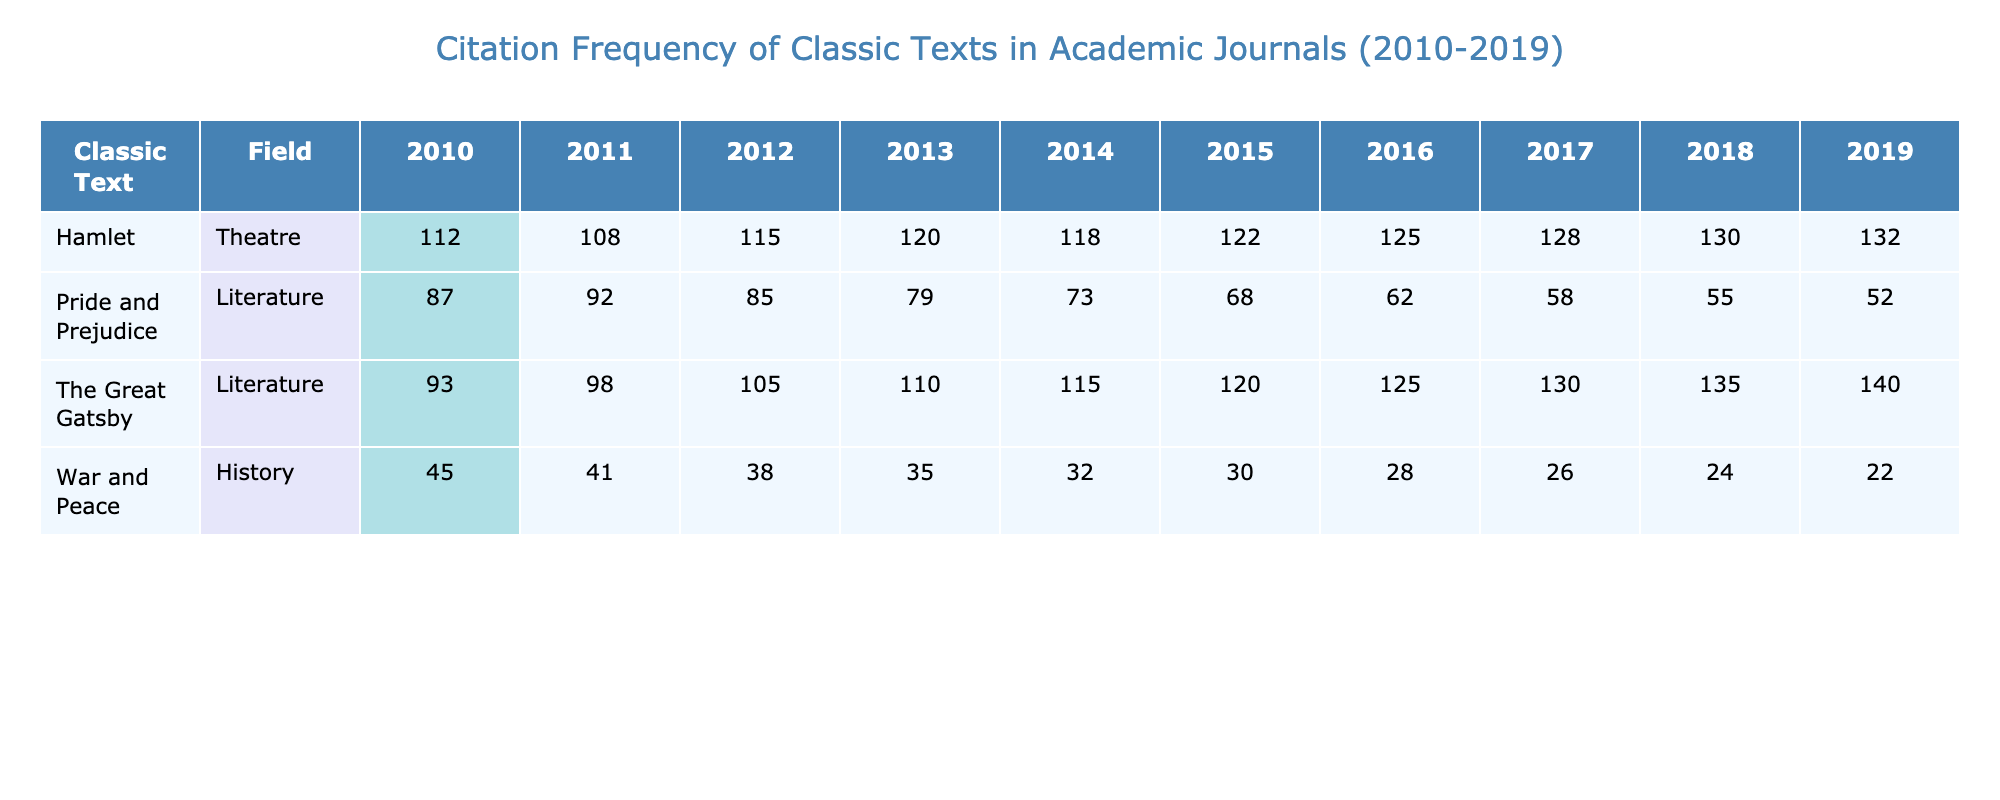What classic text had the highest number of citations in 2016? In the year 2016, the citations for the classic texts are as follows: Pride and Prejudice (62), Hamlet (125), The Great Gatsby (125), and War and Peace (28). Both Hamlet and The Great Gatsby have the highest citations at 125.
Answer: Hamlet and The Great Gatsby Which classic text consistently received the most citations across the years? By reviewing the citation counts, Hamlet received the following citations: 112, 108, 115, 120, 122, 125, 128, 130, 132. This shows a consistent upward trend and the highest range overall. Other texts show fluctuations but Hamlet is consistently among the highest per year.
Answer: Hamlet What was the difference in citations between War and Peace in 2010 and in 2019? In 2010, War and Peace had 45 citations, while in 2019 it had 22 citations. Therefore, the difference in citations is 45 - 22 = 23.
Answer: 23 Did The Great Gatsby receive more citations in 2019 than in 2010? In 2010, The Great Gatsby received 93 citations, while in 2019 it received 140 citations. Since 140 is greater than 93, the statement is true.
Answer: Yes What was the trend in citation frequency for Pride and Prejudice from 2010 to 2019? The citations for Pride and Prejudice from 2010 to 2019 are: 87, 92, 85, 79, 73, 68, 62, 58, and 55. The trend shows a consistent decline over these years, decreasing each year.
Answer: Declining trend What is the total number of citations received by The Great Gatsby over the years provided? The Great Gatsby's citation counts over the years are: 93, 98, 105, 110, 115, 120, 125, 130, 140. Adding these values gives: 93 + 98 + 105 + 110 + 115 + 120 + 125 + 130 + 140 = 1,015.
Answer: 1015 